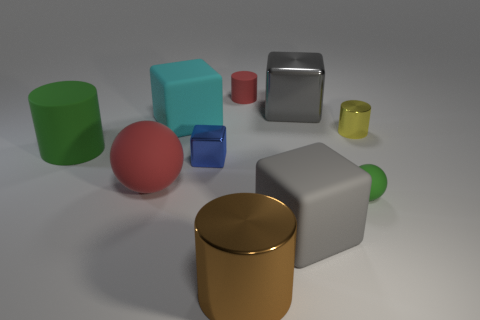Is the color of the tiny matte cylinder the same as the big matte ball?
Offer a very short reply. Yes. There is a green rubber thing that is the same size as the blue shiny object; what shape is it?
Offer a very short reply. Sphere. How many other objects are there of the same color as the tiny metallic cylinder?
Your response must be concise. 0. What number of brown objects are rubber balls or small cylinders?
Offer a terse response. 0. Does the gray object behind the gray matte block have the same shape as the metallic object that is on the right side of the small green matte sphere?
Offer a terse response. No. What number of other things are the same material as the big brown object?
Offer a very short reply. 3. Is there a gray object in front of the gray cube that is to the left of the gray metal thing that is behind the large red rubber thing?
Make the answer very short. No. Is the large brown thing made of the same material as the large red thing?
Your response must be concise. No. Are there any other things that have the same shape as the big gray metallic object?
Offer a terse response. Yes. There is a big cube that is to the right of the big matte block in front of the big cyan thing; what is its material?
Make the answer very short. Metal. 